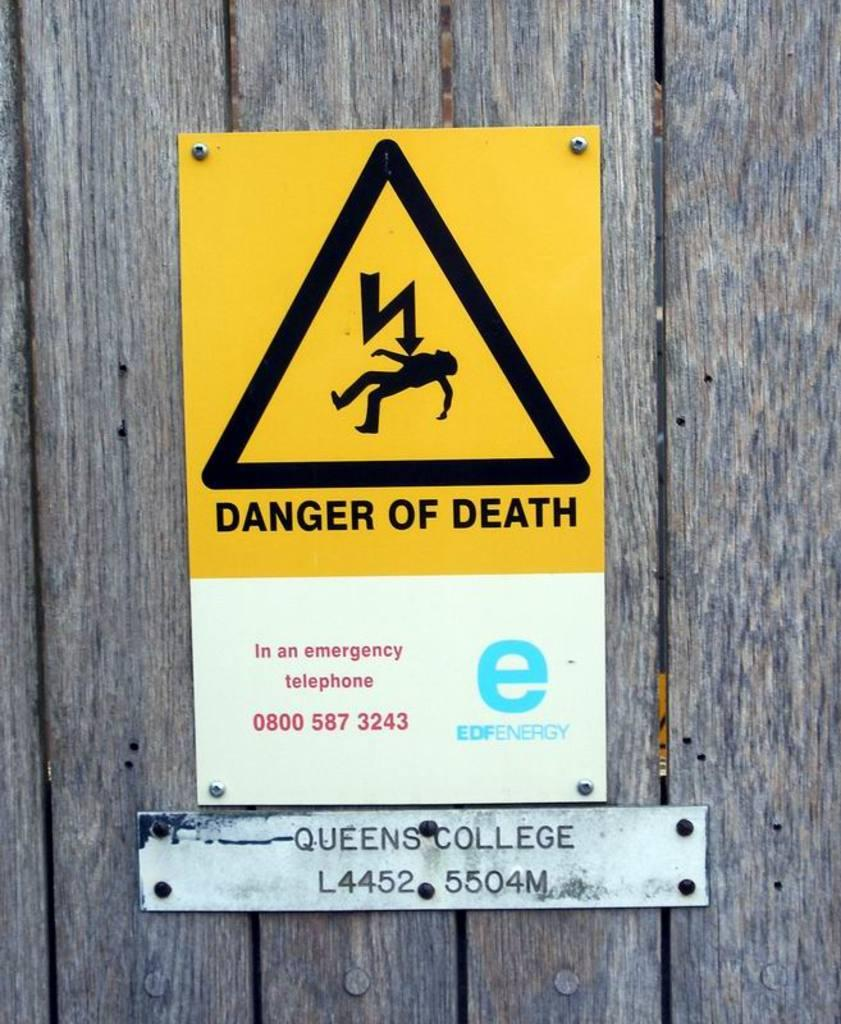<image>
Share a concise interpretation of the image provided. a danger of death sign that is on some wood 